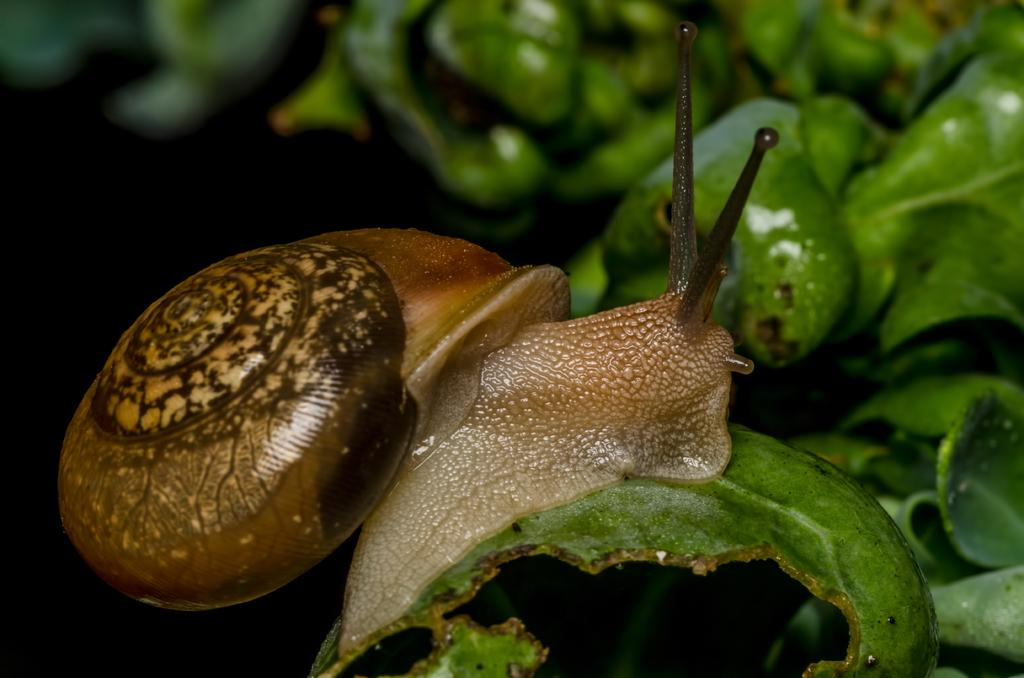What is the main subject of the image? There is a snail in the image. Where is the snail located in the image? The snail is on a plant. What colors can be seen on the snail? The snail has brown and cream colors. What can be seen in the background of the image? The background of the image includes green leaves. What type of learning is taking place at the meeting in the image? There is no meeting or learning depicted in the image; it features a snail on a plant. What kind of horn is attached to the snail in the image? There is no horn present on the snail in the image. 